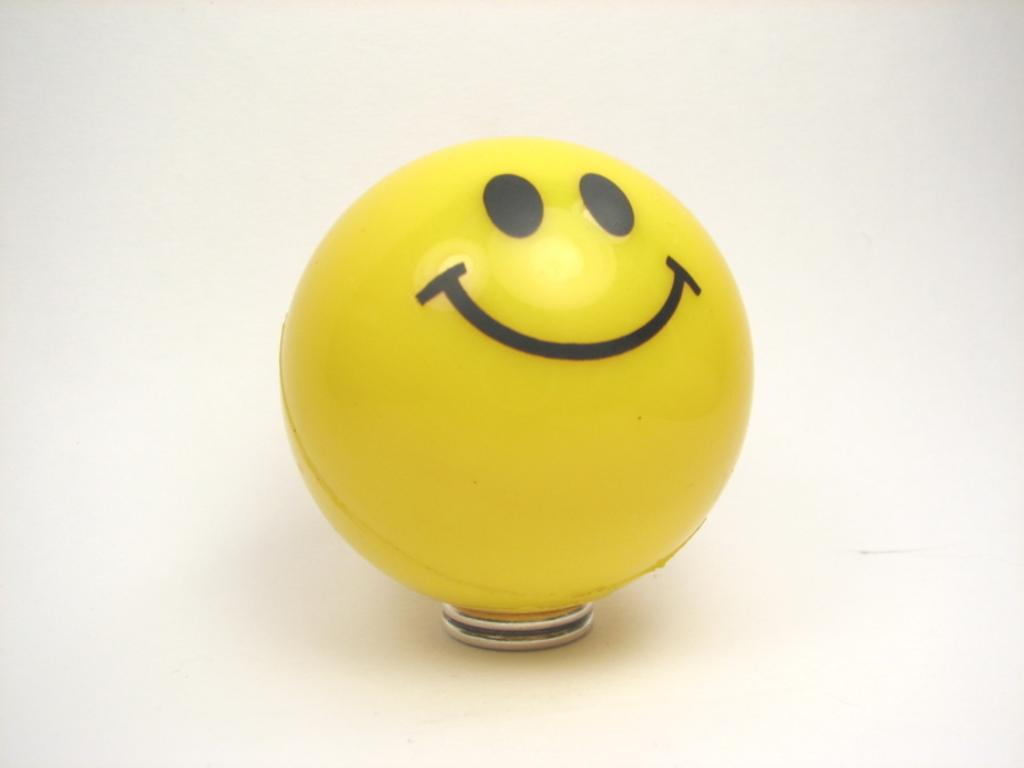What object is the main subject of the image? There is a ball in the image. What design is on the ball? The ball has a smiley emoticon on it. What type of object is below the ball? There is a metal object below the ball. What color is the background of the image? The background of the image is white. What type of sock is the baby wearing in the image? There is no baby or sock present in the image; it features a ball with a smiley emoticon and a metal object below it. What color is the yarn used to knit the hat in the image? There is no hat or yarn present in the image. 